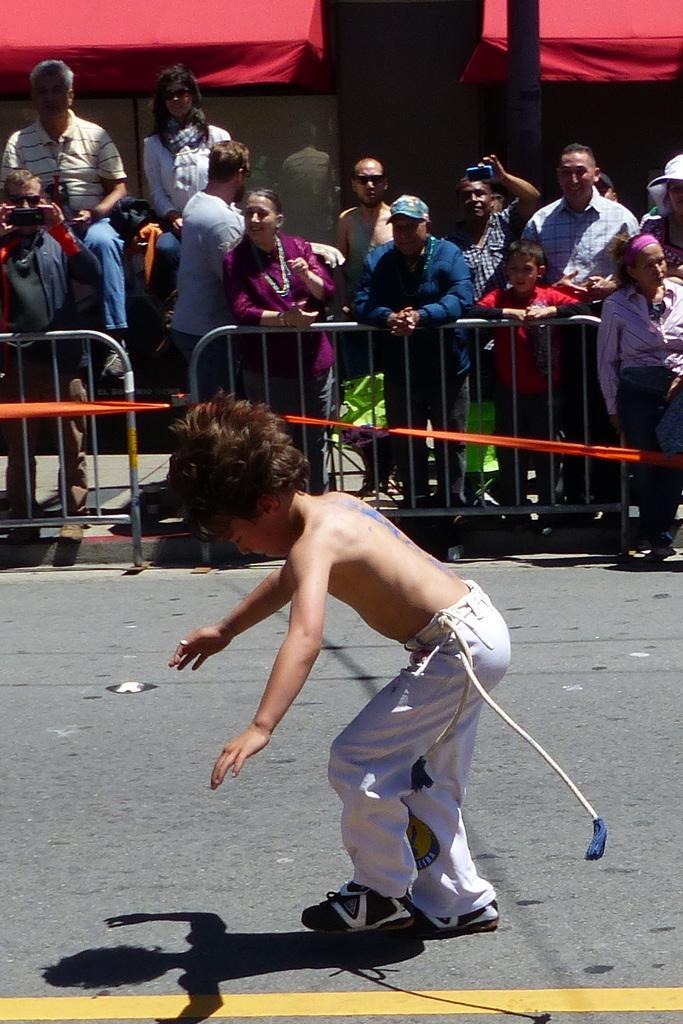In one or two sentences, can you explain what this image depicts? In the picture I can see people behind the fence. These people are holding cameras and some other objects. In front of the image I can see a boy is standing and wearing a white color pant and shoes. 